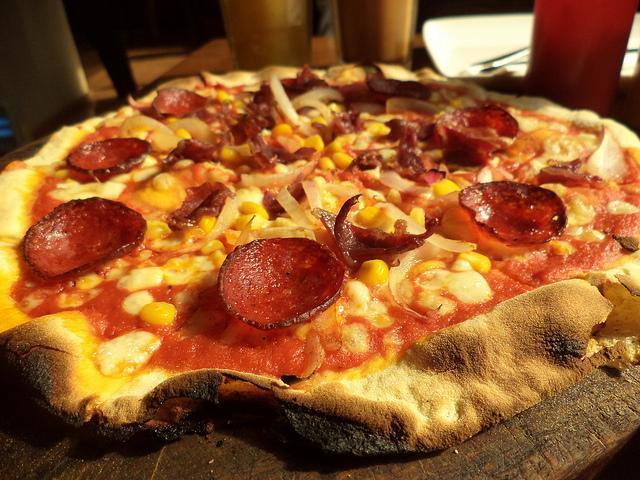How many cups are there?
Give a very brief answer. 3. How many panel partitions on the blue umbrella have writing on them?
Give a very brief answer. 0. 